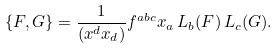<formula> <loc_0><loc_0><loc_500><loc_500>\{ F , G \} = \frac { 1 } { ( x ^ { d } x _ { d } ) } f ^ { a b c } x _ { a } \, L _ { b } ( F ) \, L _ { c } ( G ) .</formula> 